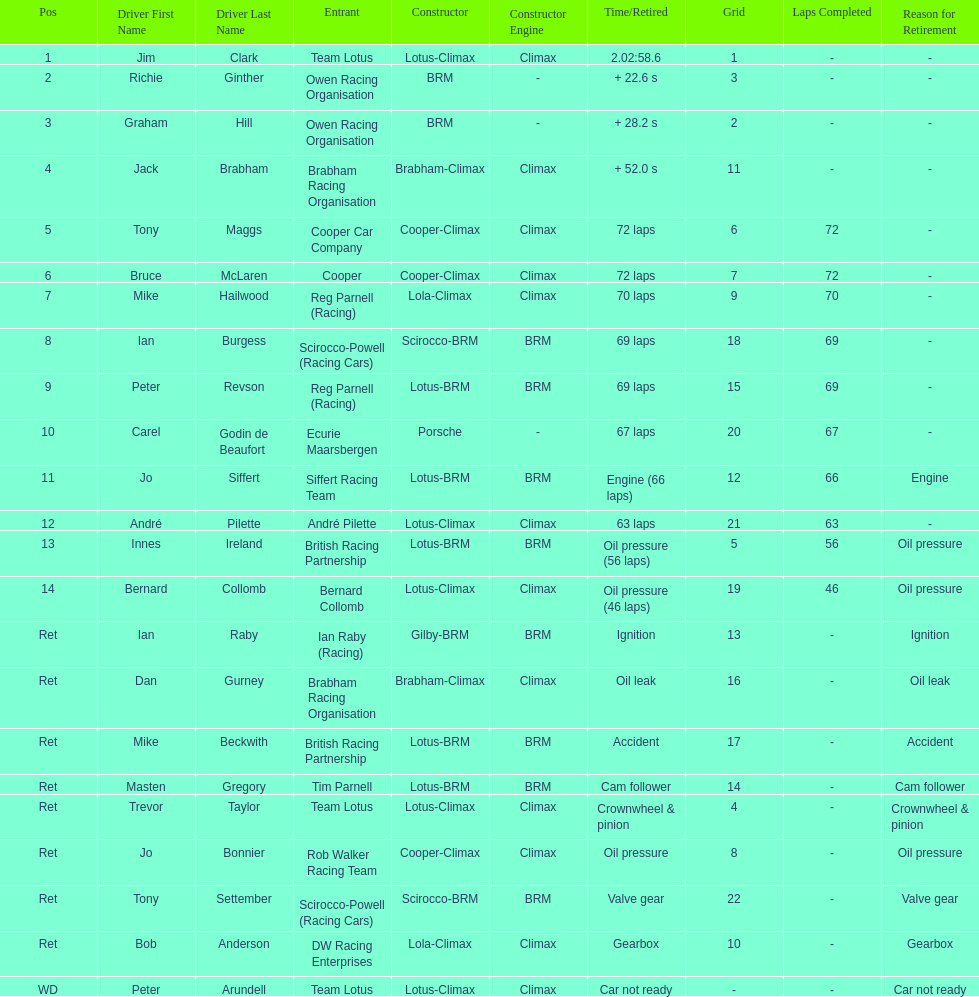Give me the full table as a dictionary. {'header': ['Pos', 'Driver First Name', 'Driver Last Name', 'Entrant', 'Constructor', 'Constructor Engine', 'Time/Retired', 'Grid', 'Laps Completed', 'Reason for Retirement'], 'rows': [['1', 'Jim', 'Clark', 'Team Lotus', 'Lotus-Climax', 'Climax', '2.02:58.6', '1', '-', '-'], ['2', 'Richie', 'Ginther', 'Owen Racing Organisation', 'BRM', '-', '+ 22.6 s', '3', '-', '-'], ['3', 'Graham', 'Hill', 'Owen Racing Organisation', 'BRM', '-', '+ 28.2 s', '2', '-', '-'], ['4', 'Jack', 'Brabham', 'Brabham Racing Organisation', 'Brabham-Climax', 'Climax', '+ 52.0 s', '11', '-', '-'], ['5', 'Tony', 'Maggs', 'Cooper Car Company', 'Cooper-Climax', 'Climax', '72 laps', '6', '72', '-'], ['6', 'Bruce', 'McLaren', 'Cooper', 'Cooper-Climax', 'Climax', '72 laps', '7', '72', '-'], ['7', 'Mike', 'Hailwood', 'Reg Parnell (Racing)', 'Lola-Climax', 'Climax', '70 laps', '9', '70', '-'], ['8', 'Ian', 'Burgess', 'Scirocco-Powell (Racing Cars)', 'Scirocco-BRM', 'BRM', '69 laps', '18', '69', '-'], ['9', 'Peter', 'Revson', 'Reg Parnell (Racing)', 'Lotus-BRM', 'BRM', '69 laps', '15', '69', '-'], ['10', 'Carel', 'Godin de Beaufort', 'Ecurie Maarsbergen', 'Porsche', '-', '67 laps', '20', '67', '-'], ['11', 'Jo', 'Siffert', 'Siffert Racing Team', 'Lotus-BRM', 'BRM', 'Engine (66 laps)', '12', '66', 'Engine'], ['12', 'André', 'Pilette', 'André Pilette', 'Lotus-Climax', 'Climax', '63 laps', '21', '63', '-'], ['13', 'Innes', 'Ireland', 'British Racing Partnership', 'Lotus-BRM', 'BRM', 'Oil pressure (56 laps)', '5', '56', 'Oil pressure'], ['14', 'Bernard', 'Collomb', 'Bernard Collomb', 'Lotus-Climax', 'Climax', 'Oil pressure (46 laps)', '19', '46', 'Oil pressure'], ['Ret', 'Ian', 'Raby', 'Ian Raby (Racing)', 'Gilby-BRM', 'BRM', 'Ignition', '13', '-', 'Ignition'], ['Ret', 'Dan', 'Gurney', 'Brabham Racing Organisation', 'Brabham-Climax', 'Climax', 'Oil leak', '16', '-', 'Oil leak'], ['Ret', 'Mike', 'Beckwith', 'British Racing Partnership', 'Lotus-BRM', 'BRM', 'Accident', '17', '-', 'Accident'], ['Ret', 'Masten', 'Gregory', 'Tim Parnell', 'Lotus-BRM', 'BRM', 'Cam follower', '14', '-', 'Cam follower'], ['Ret', 'Trevor', 'Taylor', 'Team Lotus', 'Lotus-Climax', 'Climax', 'Crownwheel & pinion', '4', '-', 'Crownwheel & pinion'], ['Ret', 'Jo', 'Bonnier', 'Rob Walker Racing Team', 'Cooper-Climax', 'Climax', 'Oil pressure', '8', '-', 'Oil pressure'], ['Ret', 'Tony', 'Settember', 'Scirocco-Powell (Racing Cars)', 'Scirocco-BRM', 'BRM', 'Valve gear', '22', '-', 'Valve gear'], ['Ret', 'Bob', 'Anderson', 'DW Racing Enterprises', 'Lola-Climax', 'Climax', 'Gearbox', '10', '-', 'Gearbox'], ['WD', 'Peter', 'Arundell', 'Team Lotus', 'Lotus-Climax', 'Climax', 'Car not ready', '-', '-', 'Car not ready']]} What was the same problem that bernard collomb had as innes ireland? Oil pressure. 